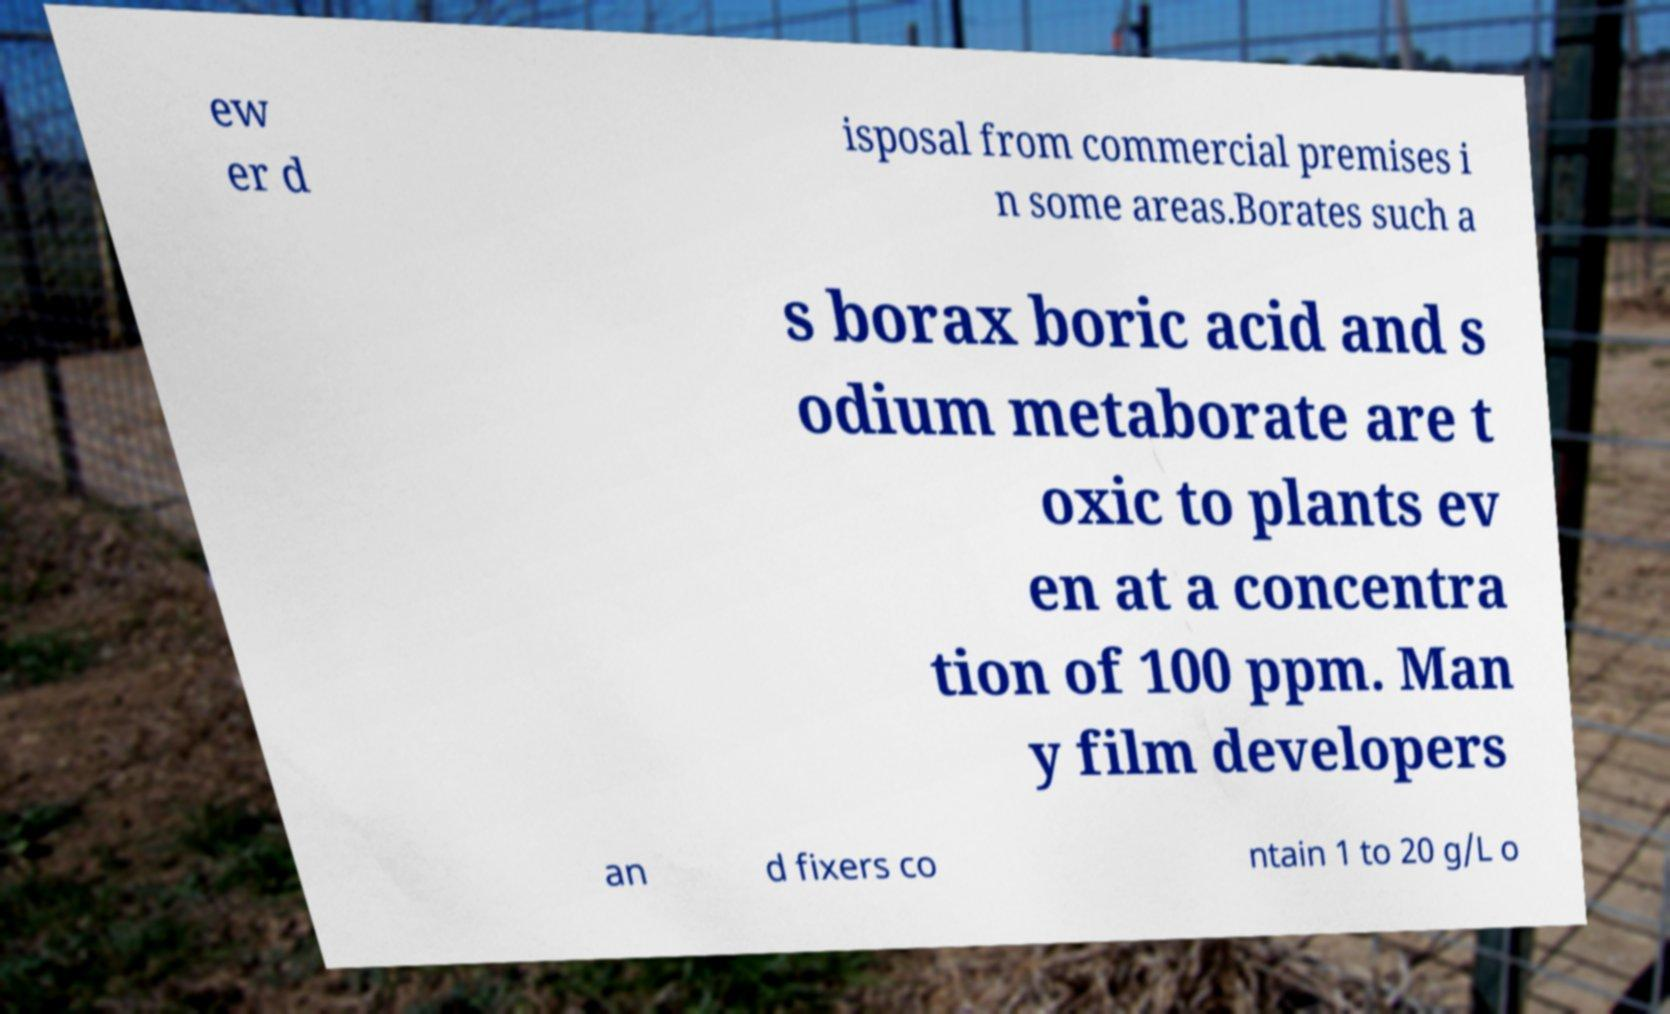For documentation purposes, I need the text within this image transcribed. Could you provide that? ew er d isposal from commercial premises i n some areas.Borates such a s borax boric acid and s odium metaborate are t oxic to plants ev en at a concentra tion of 100 ppm. Man y film developers an d fixers co ntain 1 to 20 g/L o 